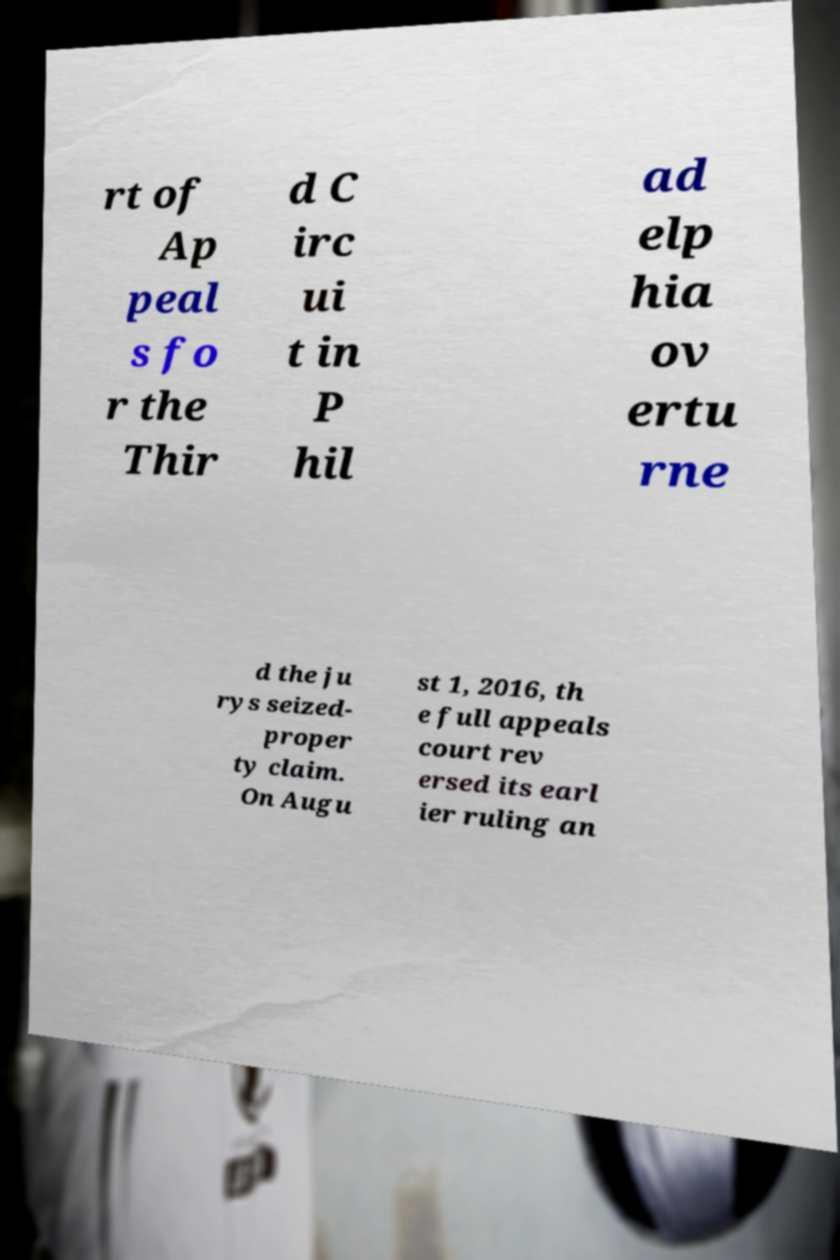There's text embedded in this image that I need extracted. Can you transcribe it verbatim? rt of Ap peal s fo r the Thir d C irc ui t in P hil ad elp hia ov ertu rne d the ju rys seized- proper ty claim. On Augu st 1, 2016, th e full appeals court rev ersed its earl ier ruling an 